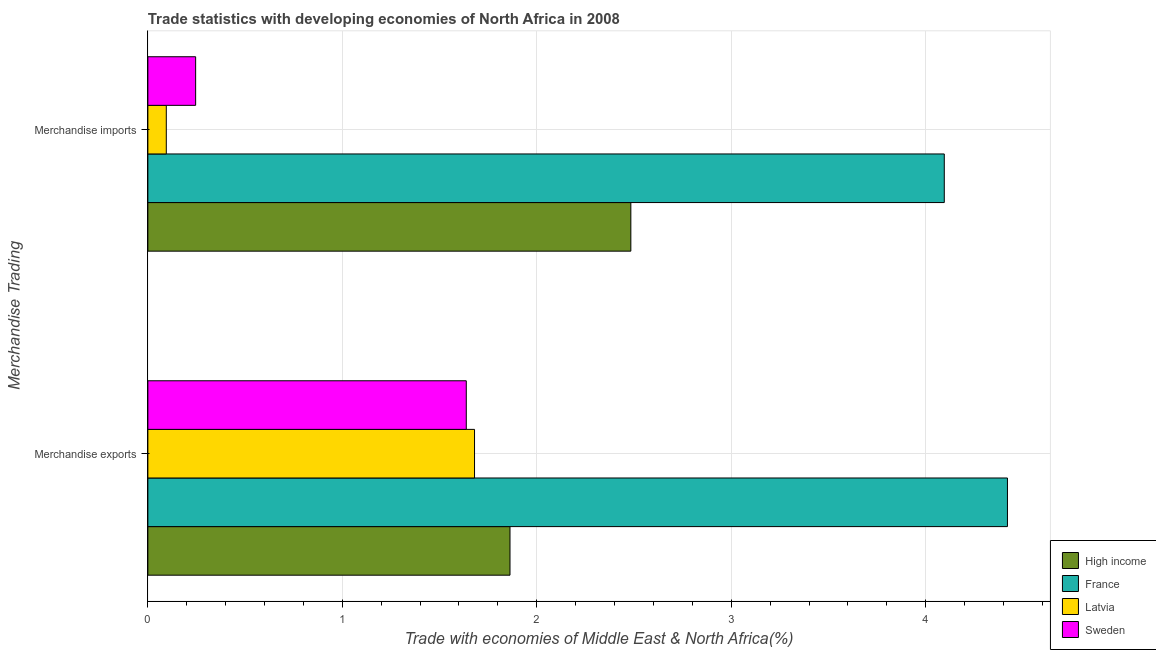How many different coloured bars are there?
Your answer should be compact. 4. Are the number of bars on each tick of the Y-axis equal?
Your response must be concise. Yes. How many bars are there on the 2nd tick from the top?
Ensure brevity in your answer.  4. What is the merchandise exports in High income?
Your answer should be very brief. 1.86. Across all countries, what is the maximum merchandise exports?
Give a very brief answer. 4.42. Across all countries, what is the minimum merchandise imports?
Give a very brief answer. 0.09. In which country was the merchandise imports maximum?
Your response must be concise. France. What is the total merchandise exports in the graph?
Your response must be concise. 9.6. What is the difference between the merchandise exports in Latvia and that in France?
Provide a succinct answer. -2.74. What is the difference between the merchandise exports in High income and the merchandise imports in Sweden?
Offer a very short reply. 1.62. What is the average merchandise imports per country?
Your answer should be compact. 1.73. What is the difference between the merchandise exports and merchandise imports in France?
Your response must be concise. 0.32. What is the ratio of the merchandise exports in Sweden to that in High income?
Your answer should be very brief. 0.88. In how many countries, is the merchandise imports greater than the average merchandise imports taken over all countries?
Offer a terse response. 2. How many bars are there?
Offer a very short reply. 8. Does the graph contain grids?
Make the answer very short. Yes. Where does the legend appear in the graph?
Provide a succinct answer. Bottom right. How are the legend labels stacked?
Offer a terse response. Vertical. What is the title of the graph?
Offer a terse response. Trade statistics with developing economies of North Africa in 2008. Does "Burkina Faso" appear as one of the legend labels in the graph?
Make the answer very short. No. What is the label or title of the X-axis?
Make the answer very short. Trade with economies of Middle East & North Africa(%). What is the label or title of the Y-axis?
Offer a very short reply. Merchandise Trading. What is the Trade with economies of Middle East & North Africa(%) in High income in Merchandise exports?
Keep it short and to the point. 1.86. What is the Trade with economies of Middle East & North Africa(%) in France in Merchandise exports?
Make the answer very short. 4.42. What is the Trade with economies of Middle East & North Africa(%) of Latvia in Merchandise exports?
Provide a short and direct response. 1.68. What is the Trade with economies of Middle East & North Africa(%) of Sweden in Merchandise exports?
Your response must be concise. 1.64. What is the Trade with economies of Middle East & North Africa(%) in High income in Merchandise imports?
Your answer should be very brief. 2.48. What is the Trade with economies of Middle East & North Africa(%) in France in Merchandise imports?
Give a very brief answer. 4.1. What is the Trade with economies of Middle East & North Africa(%) of Latvia in Merchandise imports?
Offer a terse response. 0.09. What is the Trade with economies of Middle East & North Africa(%) of Sweden in Merchandise imports?
Give a very brief answer. 0.25. Across all Merchandise Trading, what is the maximum Trade with economies of Middle East & North Africa(%) in High income?
Ensure brevity in your answer.  2.48. Across all Merchandise Trading, what is the maximum Trade with economies of Middle East & North Africa(%) of France?
Offer a terse response. 4.42. Across all Merchandise Trading, what is the maximum Trade with economies of Middle East & North Africa(%) in Latvia?
Offer a very short reply. 1.68. Across all Merchandise Trading, what is the maximum Trade with economies of Middle East & North Africa(%) in Sweden?
Provide a succinct answer. 1.64. Across all Merchandise Trading, what is the minimum Trade with economies of Middle East & North Africa(%) of High income?
Give a very brief answer. 1.86. Across all Merchandise Trading, what is the minimum Trade with economies of Middle East & North Africa(%) in France?
Provide a succinct answer. 4.1. Across all Merchandise Trading, what is the minimum Trade with economies of Middle East & North Africa(%) of Latvia?
Offer a very short reply. 0.09. Across all Merchandise Trading, what is the minimum Trade with economies of Middle East & North Africa(%) of Sweden?
Your answer should be very brief. 0.25. What is the total Trade with economies of Middle East & North Africa(%) of High income in the graph?
Ensure brevity in your answer.  4.35. What is the total Trade with economies of Middle East & North Africa(%) of France in the graph?
Offer a terse response. 8.52. What is the total Trade with economies of Middle East & North Africa(%) of Latvia in the graph?
Provide a short and direct response. 1.77. What is the total Trade with economies of Middle East & North Africa(%) in Sweden in the graph?
Your response must be concise. 1.88. What is the difference between the Trade with economies of Middle East & North Africa(%) in High income in Merchandise exports and that in Merchandise imports?
Offer a very short reply. -0.62. What is the difference between the Trade with economies of Middle East & North Africa(%) of France in Merchandise exports and that in Merchandise imports?
Offer a terse response. 0.32. What is the difference between the Trade with economies of Middle East & North Africa(%) of Latvia in Merchandise exports and that in Merchandise imports?
Your response must be concise. 1.59. What is the difference between the Trade with economies of Middle East & North Africa(%) of Sweden in Merchandise exports and that in Merchandise imports?
Offer a terse response. 1.39. What is the difference between the Trade with economies of Middle East & North Africa(%) of High income in Merchandise exports and the Trade with economies of Middle East & North Africa(%) of France in Merchandise imports?
Provide a short and direct response. -2.23. What is the difference between the Trade with economies of Middle East & North Africa(%) in High income in Merchandise exports and the Trade with economies of Middle East & North Africa(%) in Latvia in Merchandise imports?
Offer a very short reply. 1.77. What is the difference between the Trade with economies of Middle East & North Africa(%) in High income in Merchandise exports and the Trade with economies of Middle East & North Africa(%) in Sweden in Merchandise imports?
Your answer should be compact. 1.62. What is the difference between the Trade with economies of Middle East & North Africa(%) of France in Merchandise exports and the Trade with economies of Middle East & North Africa(%) of Latvia in Merchandise imports?
Keep it short and to the point. 4.33. What is the difference between the Trade with economies of Middle East & North Africa(%) in France in Merchandise exports and the Trade with economies of Middle East & North Africa(%) in Sweden in Merchandise imports?
Your answer should be compact. 4.17. What is the difference between the Trade with economies of Middle East & North Africa(%) of Latvia in Merchandise exports and the Trade with economies of Middle East & North Africa(%) of Sweden in Merchandise imports?
Provide a succinct answer. 1.43. What is the average Trade with economies of Middle East & North Africa(%) in High income per Merchandise Trading?
Ensure brevity in your answer.  2.17. What is the average Trade with economies of Middle East & North Africa(%) of France per Merchandise Trading?
Your answer should be very brief. 4.26. What is the average Trade with economies of Middle East & North Africa(%) in Latvia per Merchandise Trading?
Your answer should be compact. 0.89. What is the average Trade with economies of Middle East & North Africa(%) in Sweden per Merchandise Trading?
Give a very brief answer. 0.94. What is the difference between the Trade with economies of Middle East & North Africa(%) in High income and Trade with economies of Middle East & North Africa(%) in France in Merchandise exports?
Provide a succinct answer. -2.56. What is the difference between the Trade with economies of Middle East & North Africa(%) of High income and Trade with economies of Middle East & North Africa(%) of Latvia in Merchandise exports?
Keep it short and to the point. 0.18. What is the difference between the Trade with economies of Middle East & North Africa(%) of High income and Trade with economies of Middle East & North Africa(%) of Sweden in Merchandise exports?
Make the answer very short. 0.22. What is the difference between the Trade with economies of Middle East & North Africa(%) in France and Trade with economies of Middle East & North Africa(%) in Latvia in Merchandise exports?
Make the answer very short. 2.74. What is the difference between the Trade with economies of Middle East & North Africa(%) in France and Trade with economies of Middle East & North Africa(%) in Sweden in Merchandise exports?
Your response must be concise. 2.78. What is the difference between the Trade with economies of Middle East & North Africa(%) of Latvia and Trade with economies of Middle East & North Africa(%) of Sweden in Merchandise exports?
Your answer should be compact. 0.04. What is the difference between the Trade with economies of Middle East & North Africa(%) in High income and Trade with economies of Middle East & North Africa(%) in France in Merchandise imports?
Offer a very short reply. -1.61. What is the difference between the Trade with economies of Middle East & North Africa(%) of High income and Trade with economies of Middle East & North Africa(%) of Latvia in Merchandise imports?
Provide a succinct answer. 2.39. What is the difference between the Trade with economies of Middle East & North Africa(%) of High income and Trade with economies of Middle East & North Africa(%) of Sweden in Merchandise imports?
Your response must be concise. 2.24. What is the difference between the Trade with economies of Middle East & North Africa(%) of France and Trade with economies of Middle East & North Africa(%) of Latvia in Merchandise imports?
Make the answer very short. 4. What is the difference between the Trade with economies of Middle East & North Africa(%) of France and Trade with economies of Middle East & North Africa(%) of Sweden in Merchandise imports?
Make the answer very short. 3.85. What is the difference between the Trade with economies of Middle East & North Africa(%) of Latvia and Trade with economies of Middle East & North Africa(%) of Sweden in Merchandise imports?
Give a very brief answer. -0.15. What is the ratio of the Trade with economies of Middle East & North Africa(%) in High income in Merchandise exports to that in Merchandise imports?
Your answer should be compact. 0.75. What is the ratio of the Trade with economies of Middle East & North Africa(%) of France in Merchandise exports to that in Merchandise imports?
Make the answer very short. 1.08. What is the ratio of the Trade with economies of Middle East & North Africa(%) of Latvia in Merchandise exports to that in Merchandise imports?
Provide a short and direct response. 17.72. What is the ratio of the Trade with economies of Middle East & North Africa(%) in Sweden in Merchandise exports to that in Merchandise imports?
Offer a terse response. 6.67. What is the difference between the highest and the second highest Trade with economies of Middle East & North Africa(%) in High income?
Give a very brief answer. 0.62. What is the difference between the highest and the second highest Trade with economies of Middle East & North Africa(%) of France?
Your answer should be very brief. 0.32. What is the difference between the highest and the second highest Trade with economies of Middle East & North Africa(%) in Latvia?
Provide a succinct answer. 1.59. What is the difference between the highest and the second highest Trade with economies of Middle East & North Africa(%) of Sweden?
Your answer should be very brief. 1.39. What is the difference between the highest and the lowest Trade with economies of Middle East & North Africa(%) in High income?
Provide a short and direct response. 0.62. What is the difference between the highest and the lowest Trade with economies of Middle East & North Africa(%) of France?
Your answer should be compact. 0.32. What is the difference between the highest and the lowest Trade with economies of Middle East & North Africa(%) of Latvia?
Keep it short and to the point. 1.59. What is the difference between the highest and the lowest Trade with economies of Middle East & North Africa(%) in Sweden?
Keep it short and to the point. 1.39. 